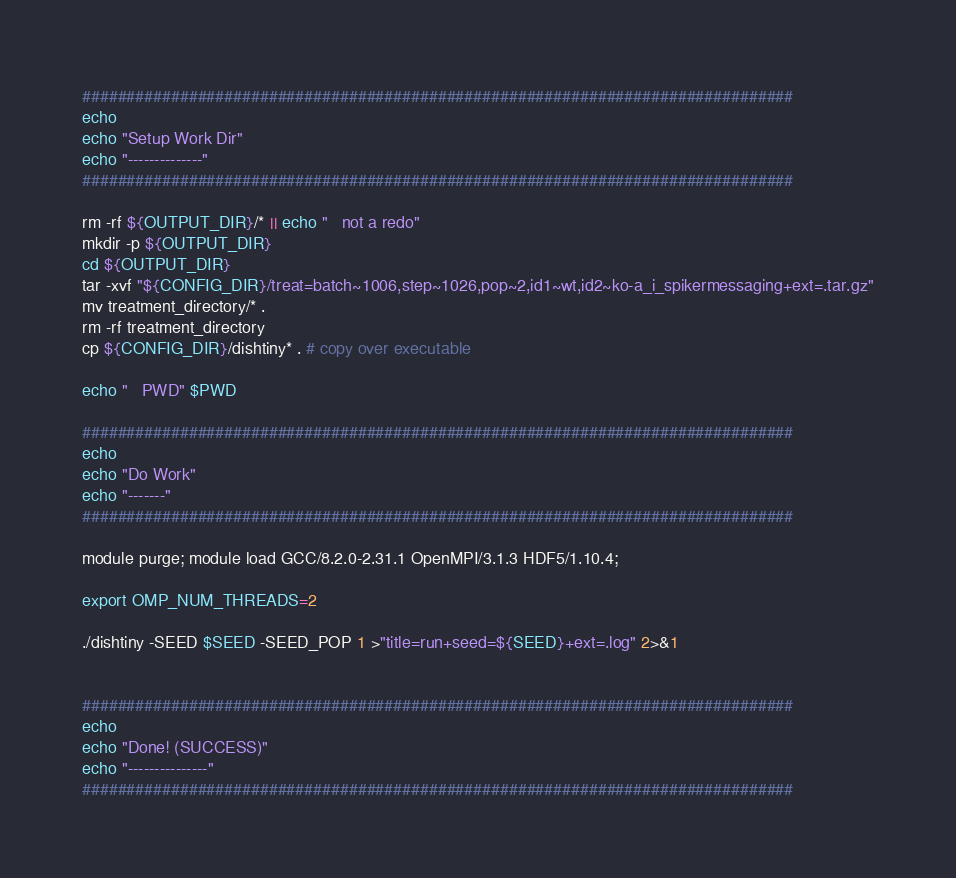Convert code to text. <code><loc_0><loc_0><loc_500><loc_500><_Bash_>
################################################################################
echo
echo "Setup Work Dir"
echo "--------------"
################################################################################

rm -rf ${OUTPUT_DIR}/* || echo "   not a redo"
mkdir -p ${OUTPUT_DIR}
cd ${OUTPUT_DIR}
tar -xvf "${CONFIG_DIR}/treat=batch~1006,step~1026,pop~2,id1~wt,id2~ko-a_i_spikermessaging+ext=.tar.gz"
mv treatment_directory/* .
rm -rf treatment_directory
cp ${CONFIG_DIR}/dishtiny* . # copy over executable

echo "   PWD" $PWD

################################################################################
echo
echo "Do Work"
echo "-------"
################################################################################

module purge; module load GCC/8.2.0-2.31.1 OpenMPI/3.1.3 HDF5/1.10.4;

export OMP_NUM_THREADS=2

./dishtiny -SEED $SEED -SEED_POP 1 >"title=run+seed=${SEED}+ext=.log" 2>&1


################################################################################
echo
echo "Done! (SUCCESS)"
echo "---------------"
################################################################################
</code> 